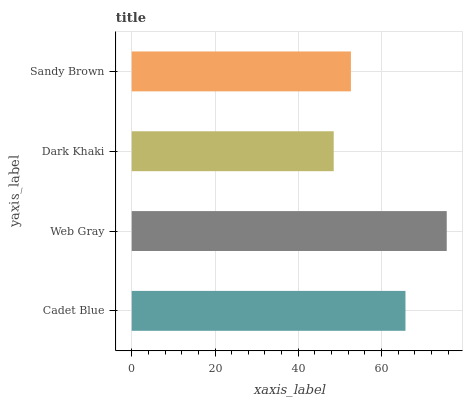Is Dark Khaki the minimum?
Answer yes or no. Yes. Is Web Gray the maximum?
Answer yes or no. Yes. Is Web Gray the minimum?
Answer yes or no. No. Is Dark Khaki the maximum?
Answer yes or no. No. Is Web Gray greater than Dark Khaki?
Answer yes or no. Yes. Is Dark Khaki less than Web Gray?
Answer yes or no. Yes. Is Dark Khaki greater than Web Gray?
Answer yes or no. No. Is Web Gray less than Dark Khaki?
Answer yes or no. No. Is Cadet Blue the high median?
Answer yes or no. Yes. Is Sandy Brown the low median?
Answer yes or no. Yes. Is Web Gray the high median?
Answer yes or no. No. Is Cadet Blue the low median?
Answer yes or no. No. 